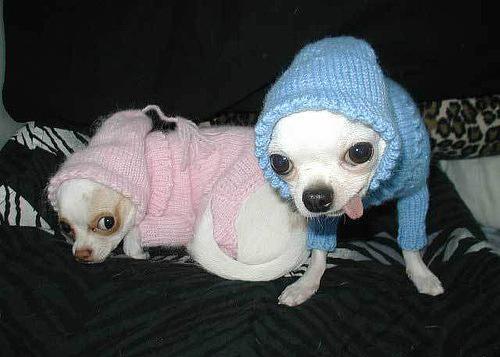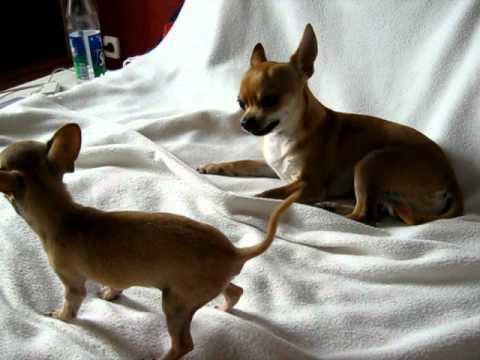The first image is the image on the left, the second image is the image on the right. Analyze the images presented: Is the assertion "Two chihuahuas in different poses are posed together indoors wearing some type of garment." valid? Answer yes or no. Yes. The first image is the image on the left, the second image is the image on the right. Given the left and right images, does the statement "Exactly four dogs are shown, two in each image, with two in one image wearing outer wear, each in a different color, even though they are inside." hold true? Answer yes or no. Yes. 